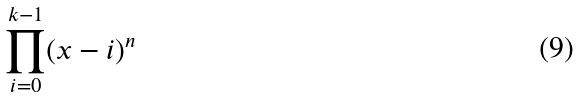Convert formula to latex. <formula><loc_0><loc_0><loc_500><loc_500>\prod _ { i = 0 } ^ { k - 1 } ( x - i ) ^ { n }</formula> 